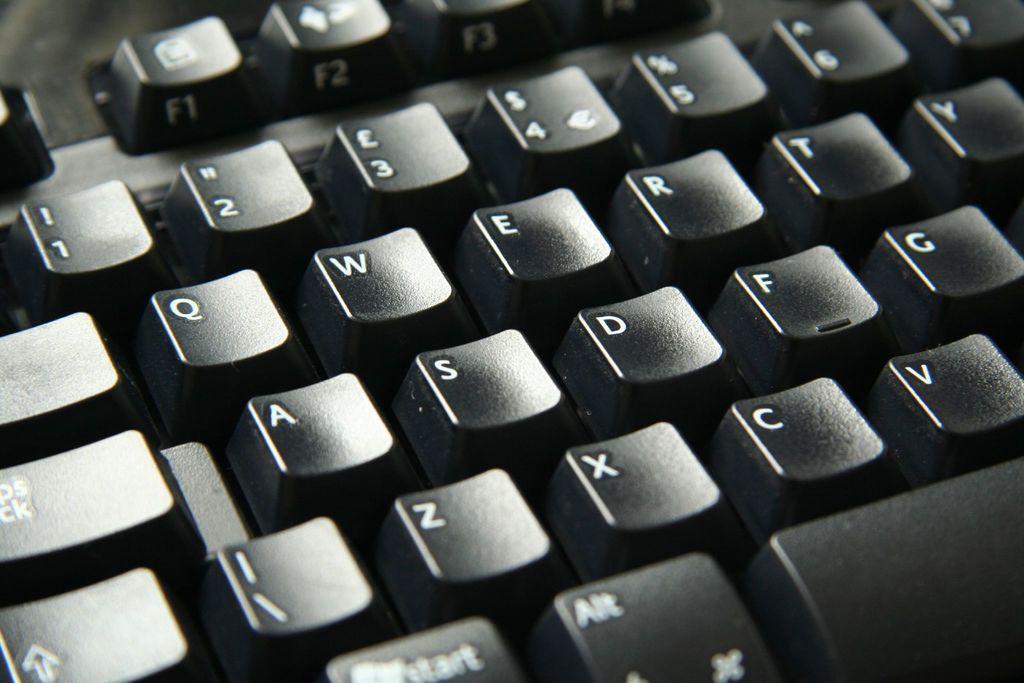What is the last number shown on the keyboard?
Your answer should be compact. 7. What is the letter beneath the number one?
Keep it short and to the point. Q. 